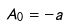<formula> <loc_0><loc_0><loc_500><loc_500>A _ { 0 } = - a</formula> 